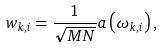<formula> <loc_0><loc_0><loc_500><loc_500>w _ { k , i } = \frac { 1 } { \sqrt { M N } } a \left ( \omega _ { k , i } \right ) ,</formula> 